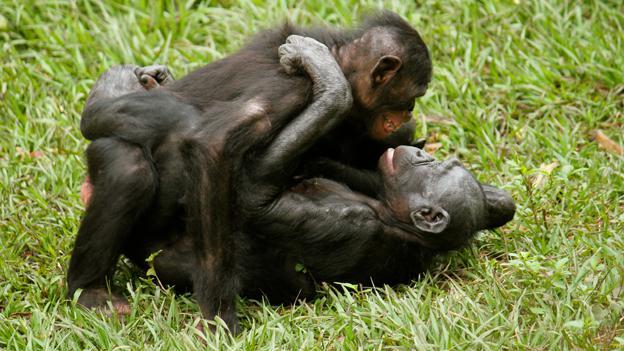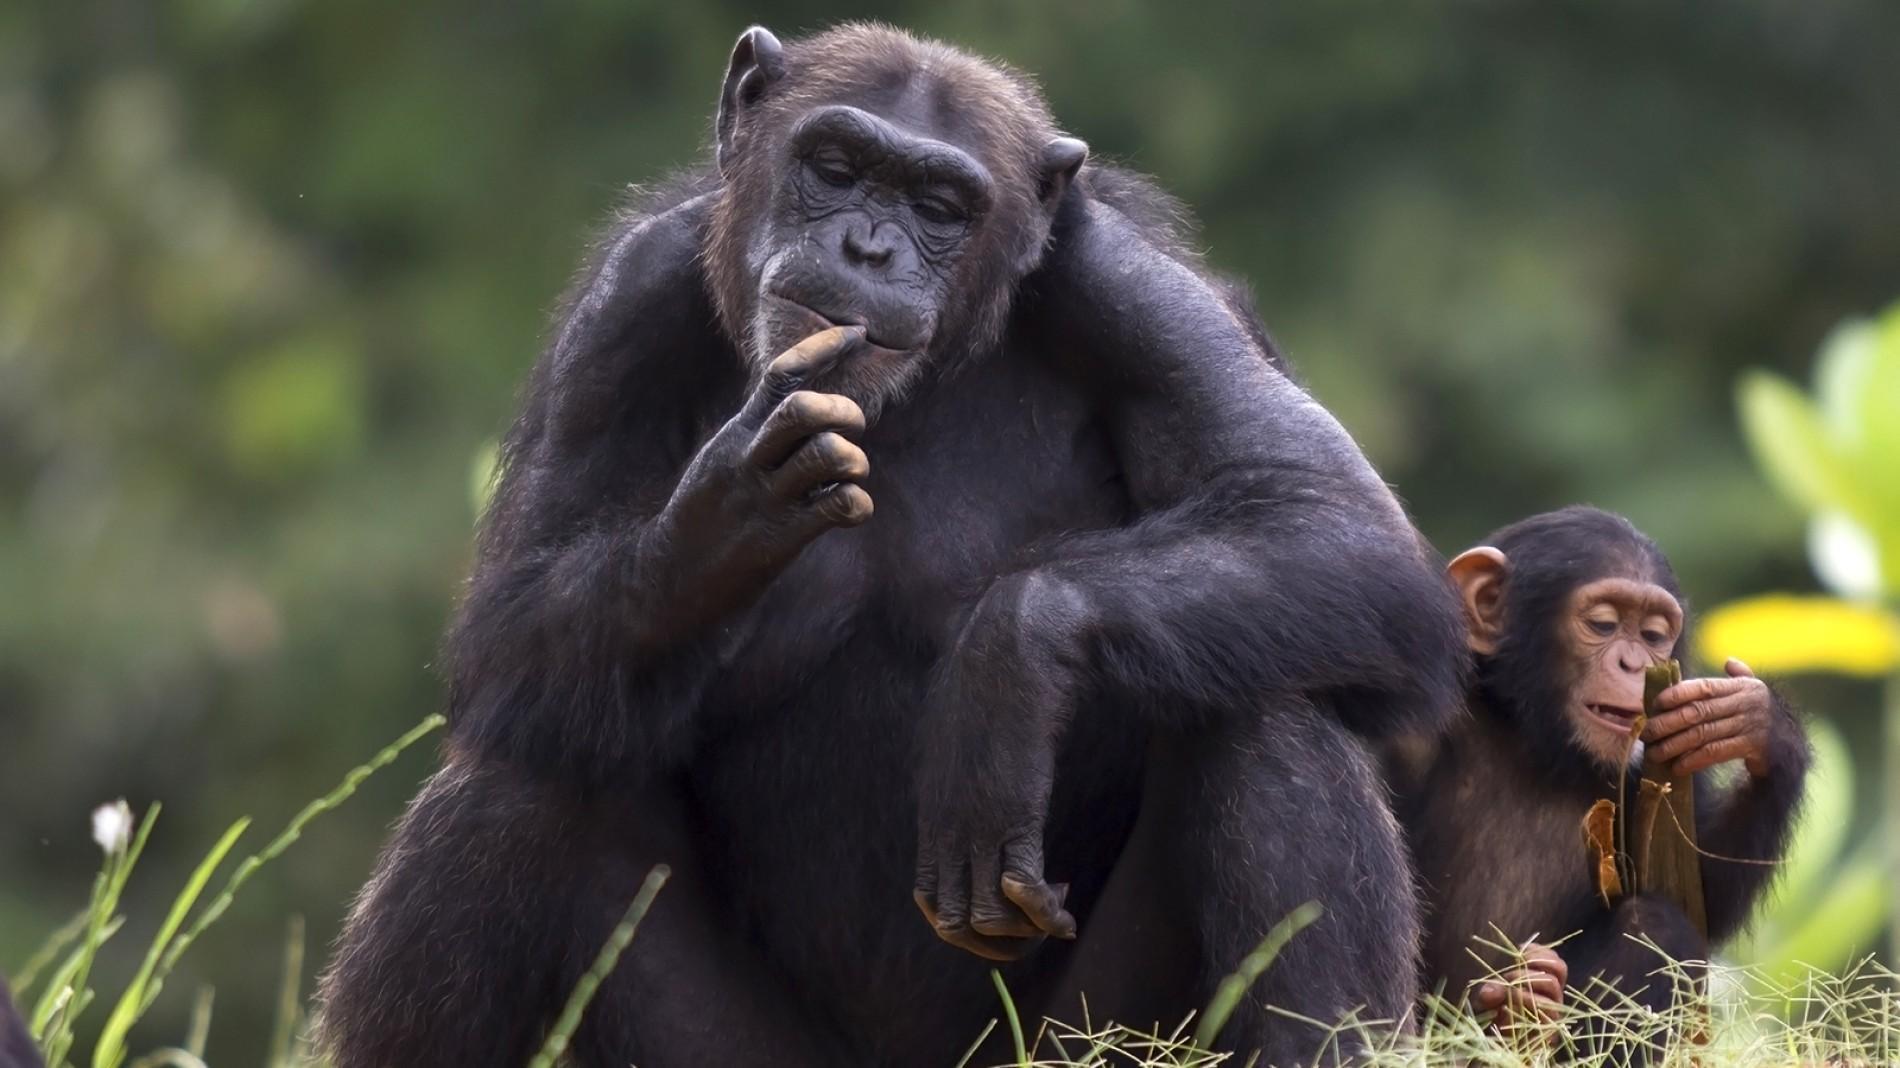The first image is the image on the left, the second image is the image on the right. Evaluate the accuracy of this statement regarding the images: "Each image shows a larger animal hugging a smaller one.". Is it true? Answer yes or no. No. 